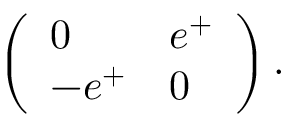Convert formula to latex. <formula><loc_0><loc_0><loc_500><loc_500>\left ( \begin{array} { l l } { 0 } & { { e ^ { + } } } \\ { { - e ^ { + } } } & { 0 } \end{array} \right ) .</formula> 